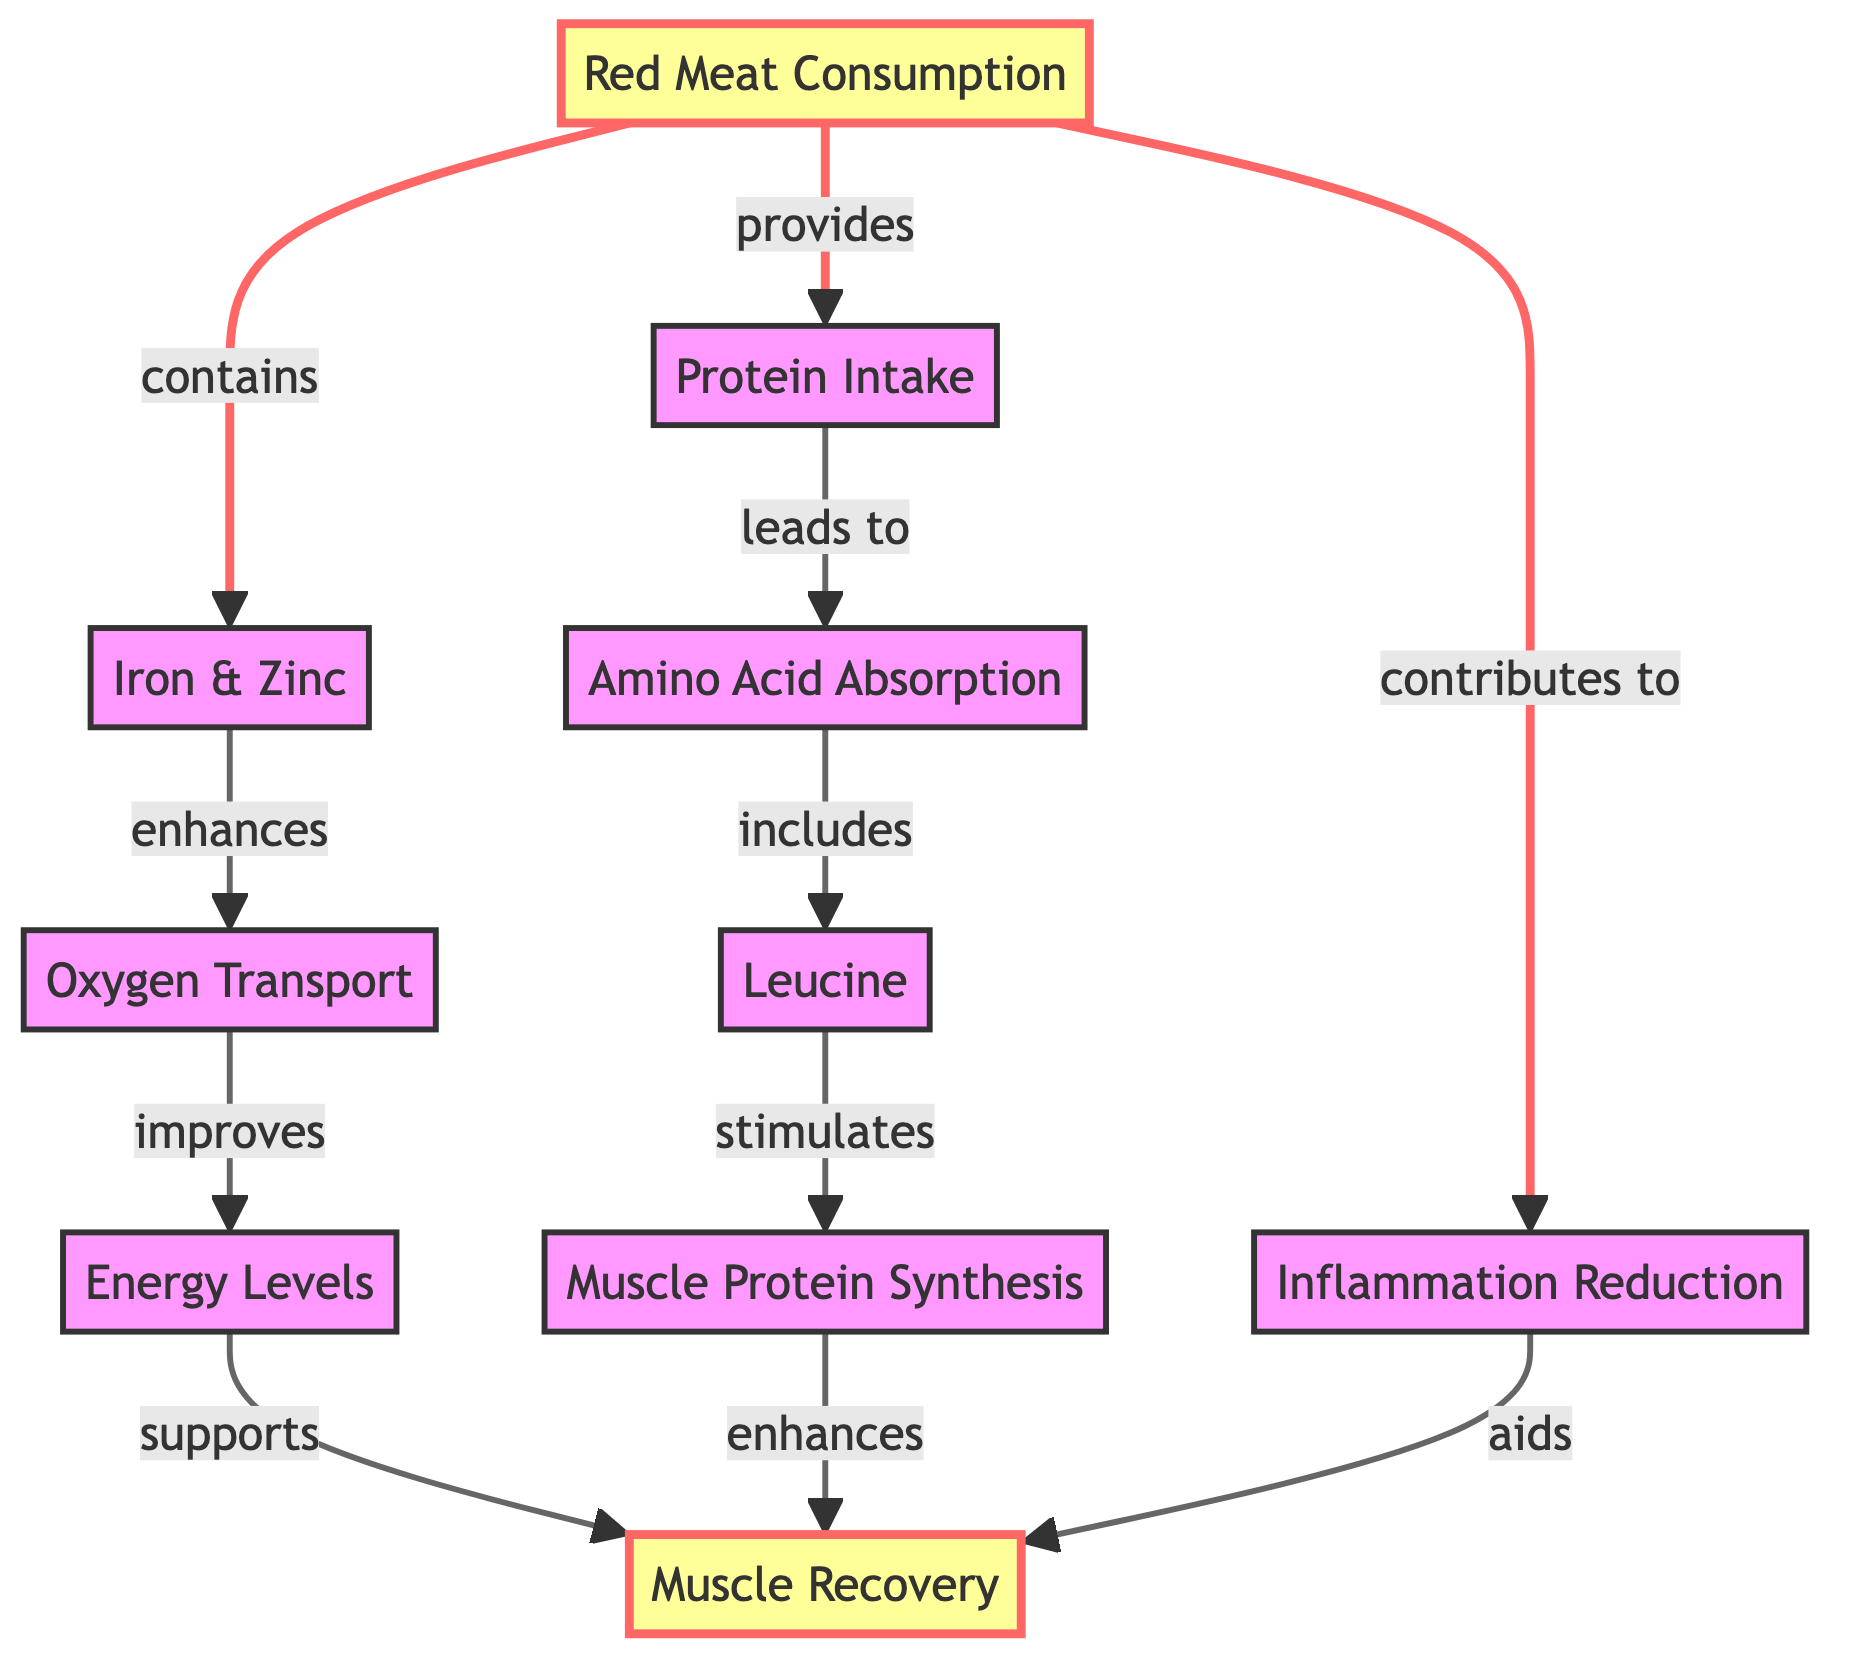What is the main factor provided by red meat consumption? The diagram indicates that red meat consumption provides protein intake, which is the primary factor linked to muscle recovery.
Answer: Protein Intake How many nodes represent the benefits of red meat consumption? The diagram features eight nodes that illustrate various benefits linked to red meat consumption, such as muscle protein synthesis and inflammation reduction.
Answer: 8 Which amino acid is specifically highlighted in the diagram? The diagram points out leucine as a key amino acid that stimulates muscle protein synthesis, showing its importance in muscle recovery processes.
Answer: Leucine What relationship exists between muscle protein synthesis and muscle recovery? The diagram shows that enhanced muscle protein synthesis directly contributes to improved muscle recovery, illustrating a clear connection between these two factors.
Answer: Enhances Which nutrients from red meat enhance oxygen transport? According to the diagram, iron and zinc are the specific nutrients from red meat responsible for enhancing oxygen transport, thereby aiding in improved energy levels and muscle recovery.
Answer: Iron & Zinc How does inflammation reduction affect muscle recovery? The diagram indicates that inflammation reduction aids muscle recovery, providing a link between reduced inflammation and improved recovery outcomes after exercise or strain.
Answer: Aids What is the final outcome of improved energy levels as per the diagram? The flowchart shows that improved energy levels support muscle recovery, indicating that higher energy availability is beneficial for recovery processes in muscle tissue.
Answer: Supports How does protein intake lead to amino acid absorption? The diagram states that protein intake leads to amino acid absorption, outlining the sequential process that occurs following the consumption of red meat and its protein content.
Answer: Leads to What role does oxidizing transport play in recovery according to the diagram? In the framework of the diagram, oxygen transport improves energy levels, which subsequently supports muscle recovery, illustrating its role in overall recovery.
Answer: Improves 